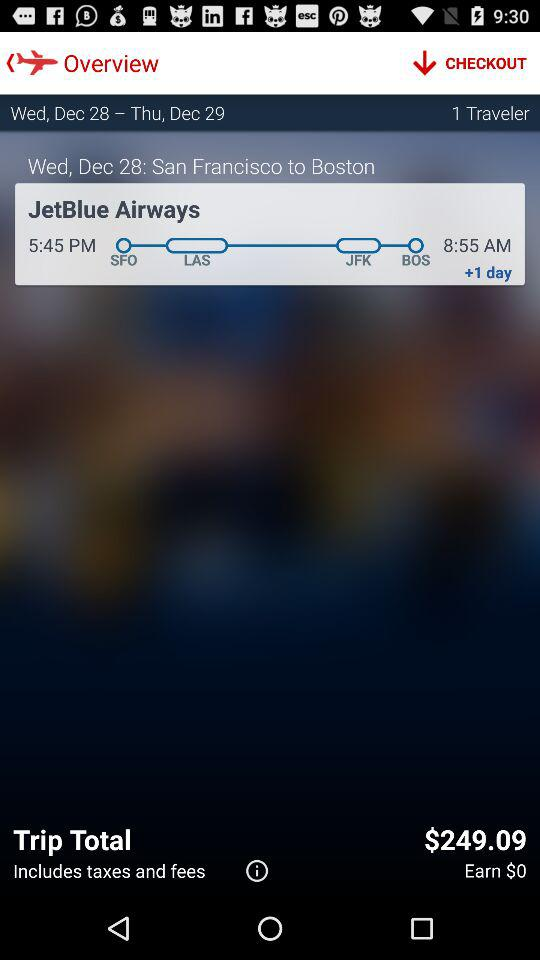What is the name of the given airline? The name is "JetBlue Airways". 